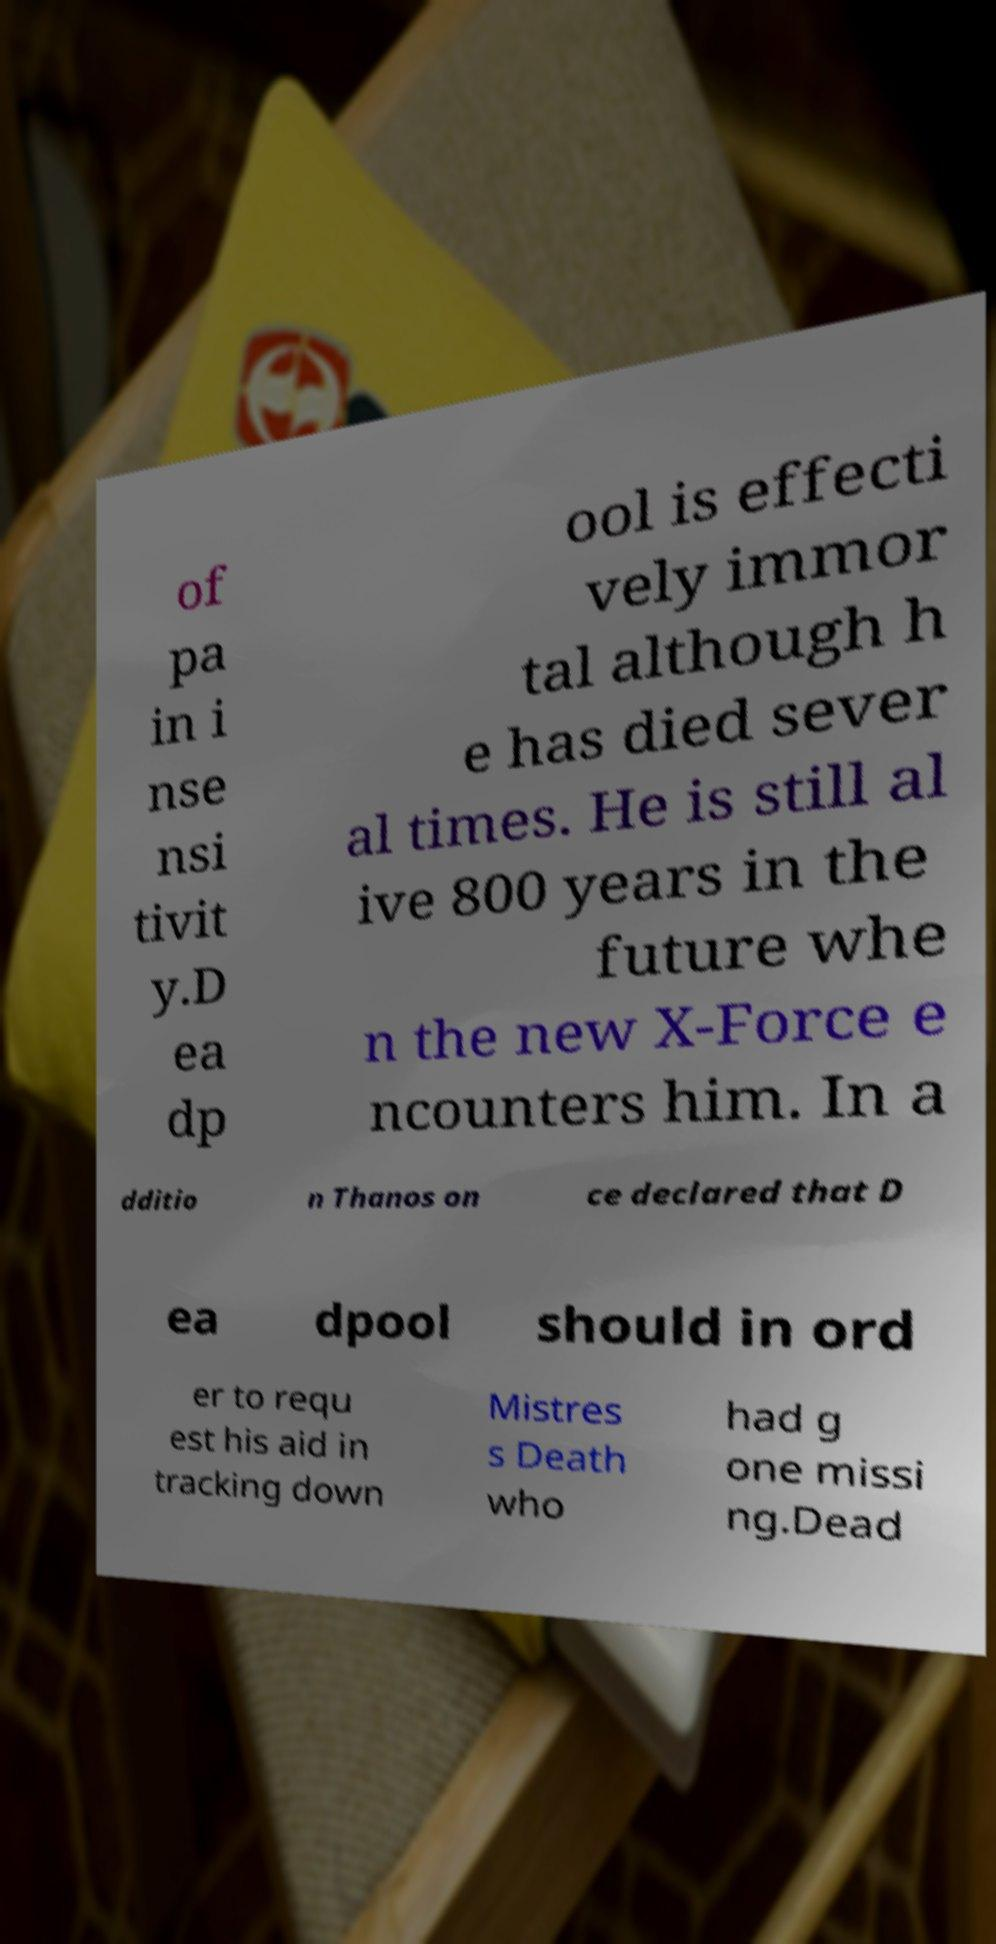What messages or text are displayed in this image? I need them in a readable, typed format. of pa in i nse nsi tivit y.D ea dp ool is effecti vely immor tal although h e has died sever al times. He is still al ive 800 years in the future whe n the new X-Force e ncounters him. In a dditio n Thanos on ce declared that D ea dpool should in ord er to requ est his aid in tracking down Mistres s Death who had g one missi ng.Dead 